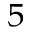Convert formula to latex. <formula><loc_0><loc_0><loc_500><loc_500>^ { 5 }</formula> 